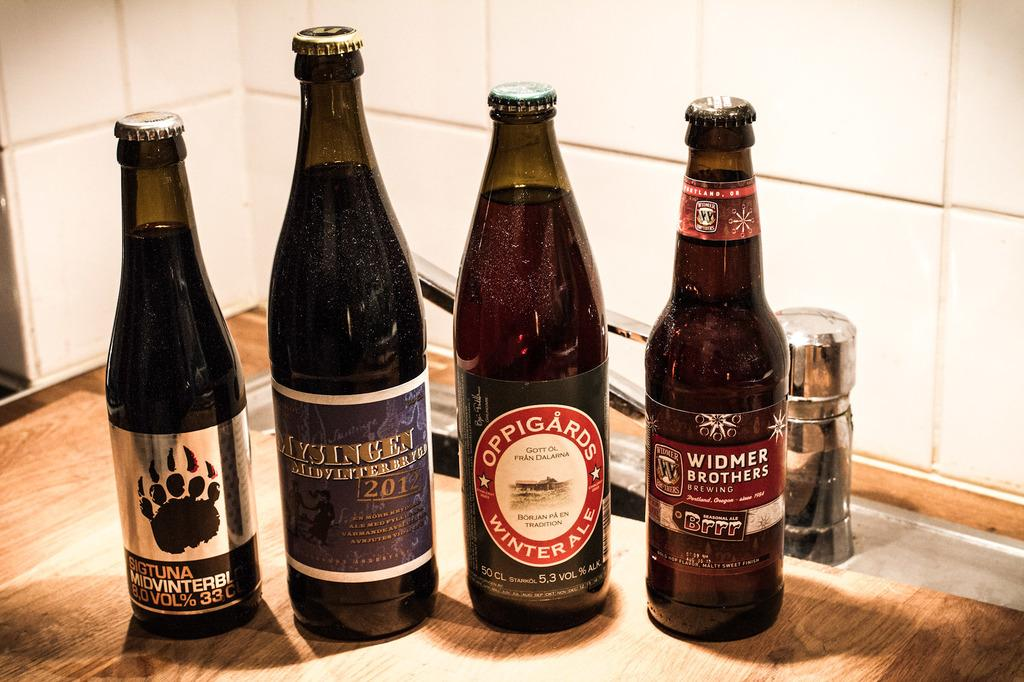<image>
Share a concise interpretation of the image provided. Four bottles of beer including Oppigards Winter Ale are sitting on a table. 